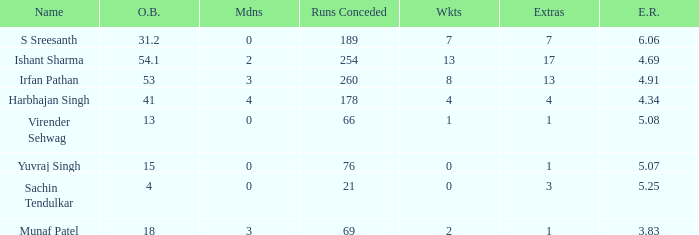2 overs have been bowled. S Sreesanth. 